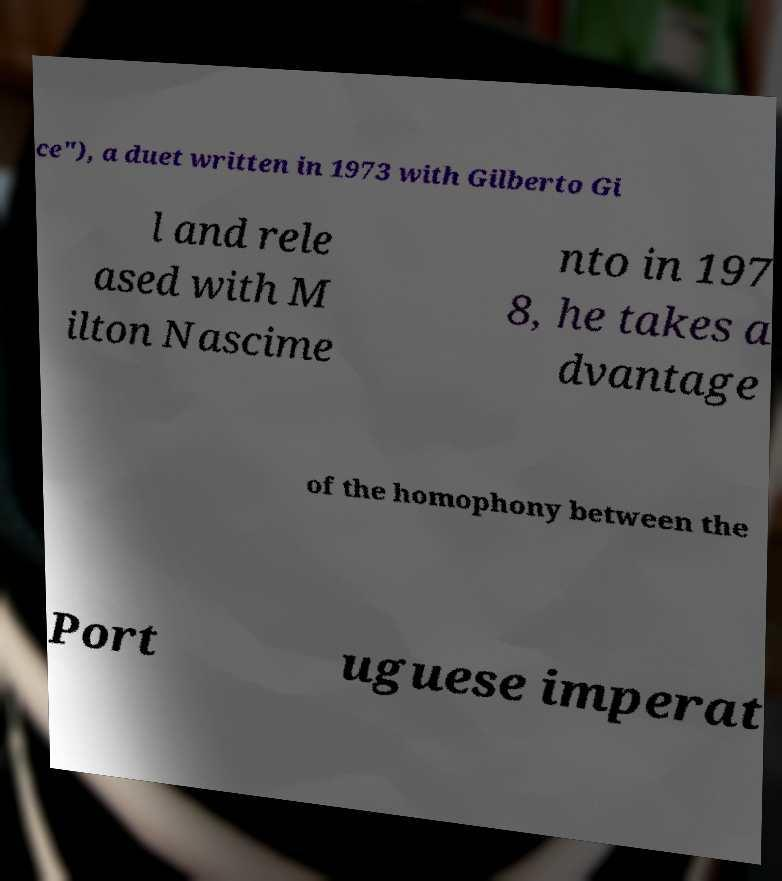I need the written content from this picture converted into text. Can you do that? ce"), a duet written in 1973 with Gilberto Gi l and rele ased with M ilton Nascime nto in 197 8, he takes a dvantage of the homophony between the Port uguese imperat 